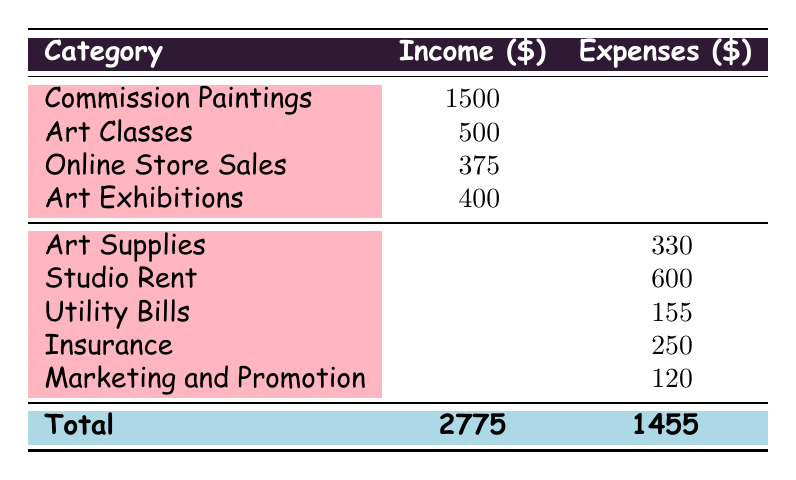What is the total income from commission paintings? The total income from commission paintings is listed directly in the table under the Income column. It shows a total of 1500.
Answer: 1500 What is the total monthly expenses? The total monthly expenses can be found in the last row of the Expenses column. The total is indicated as 1455.
Answer: 1455 How much did the artist earn from art classes? The income from art classes is displayed in the table with a total of 500.
Answer: 500 What are the total expenses for art supplies? The total expenses for art supplies, which includes paints, canvases, brushes, and other supplies, is summarized in the table as 330.
Answer: 330 Is the total income greater than total expenses? To verify this, compare the total income of 2775 with the total expenses of 1455. Since 2775 is greater than 1455, the statement is true.
Answer: Yes How much did the artist earn from online store sales compared to art exhibitions? The income from online store sales is 375, while from art exhibitions, it is 400. The artist earned 25 more from art exhibitions than from online store sales.
Answer: 25 more What percentage of the total income comes from commission paintings? The percentage can be calculated by taking the total income from commission paintings (1500) and dividing it by total income (2775), then multiplying by 100. This gives (1500/2775)*100 ≈ 54.1%.
Answer: Approximately 54.1% What is the combined total of utility bills and marketing expenses? To find the combined total, add the utility bills (155) to marketing expenses (120). So, 155 + 120 = 275.
Answer: 275 How do the monthly expenses for insurance compare to studio rent? The monthly expenses for insurance total 250, while studio rent is 600. Since 250 is less than 600, insurance costs are lower.
Answer: Insurance is lower 